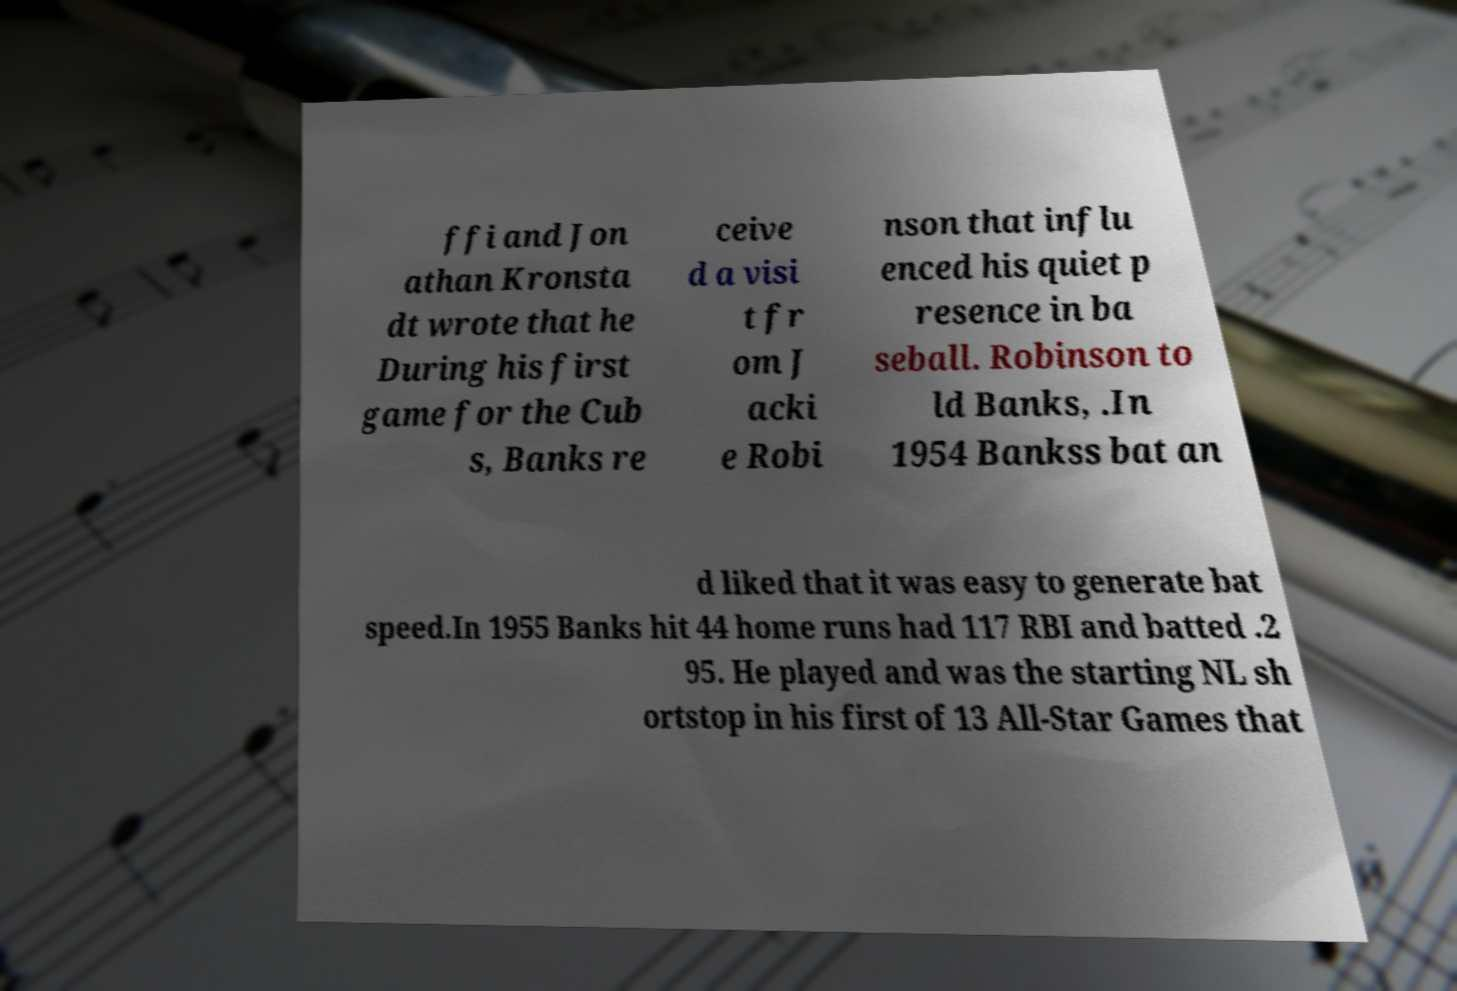For documentation purposes, I need the text within this image transcribed. Could you provide that? ffi and Jon athan Kronsta dt wrote that he During his first game for the Cub s, Banks re ceive d a visi t fr om J acki e Robi nson that influ enced his quiet p resence in ba seball. Robinson to ld Banks, .In 1954 Bankss bat an d liked that it was easy to generate bat speed.In 1955 Banks hit 44 home runs had 117 RBI and batted .2 95. He played and was the starting NL sh ortstop in his first of 13 All-Star Games that 